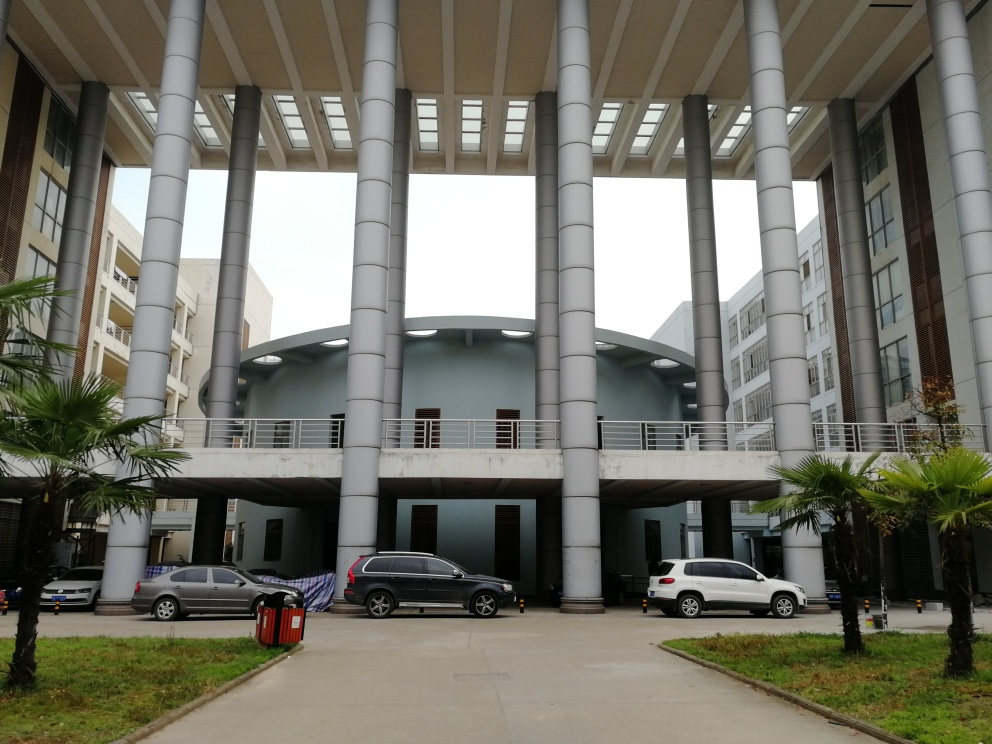Is there any underexposure in the image? Based on the analysis of the image provided, there is no significant underexposure present. The light is well-distributed across the architectural features, and there is good visibility in the areas that could potentially be prone to shadow, such as beneath the walkways and cars. Both brighter and darker regions maintain detail without substantial loss, which is indicative of a balanced exposure. 